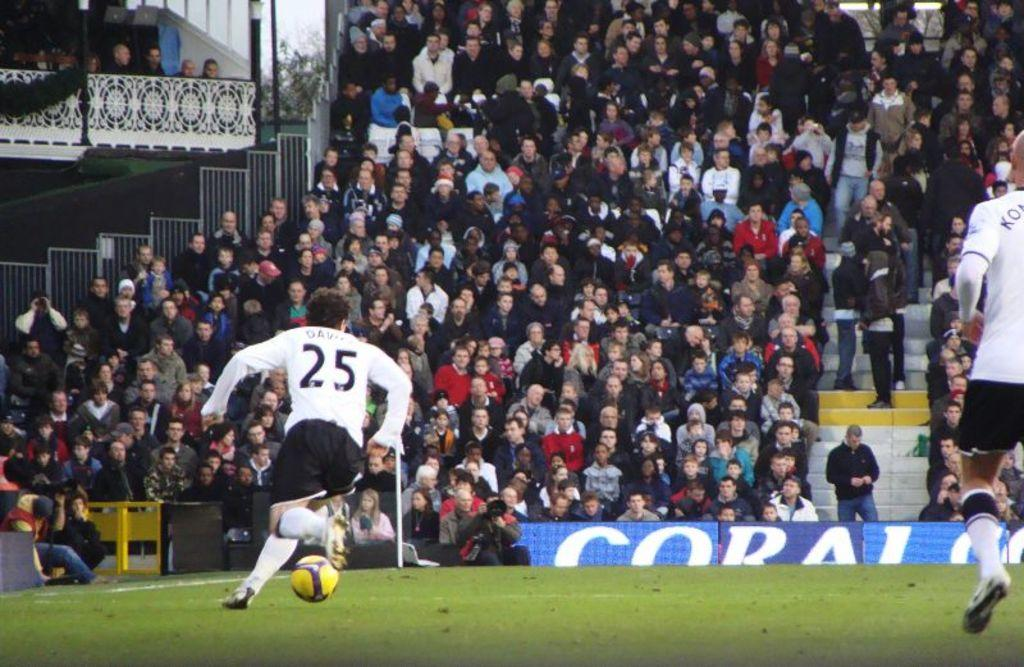Provide a one-sentence caption for the provided image. Number 25, Davis, dribbles the ball down the field. 